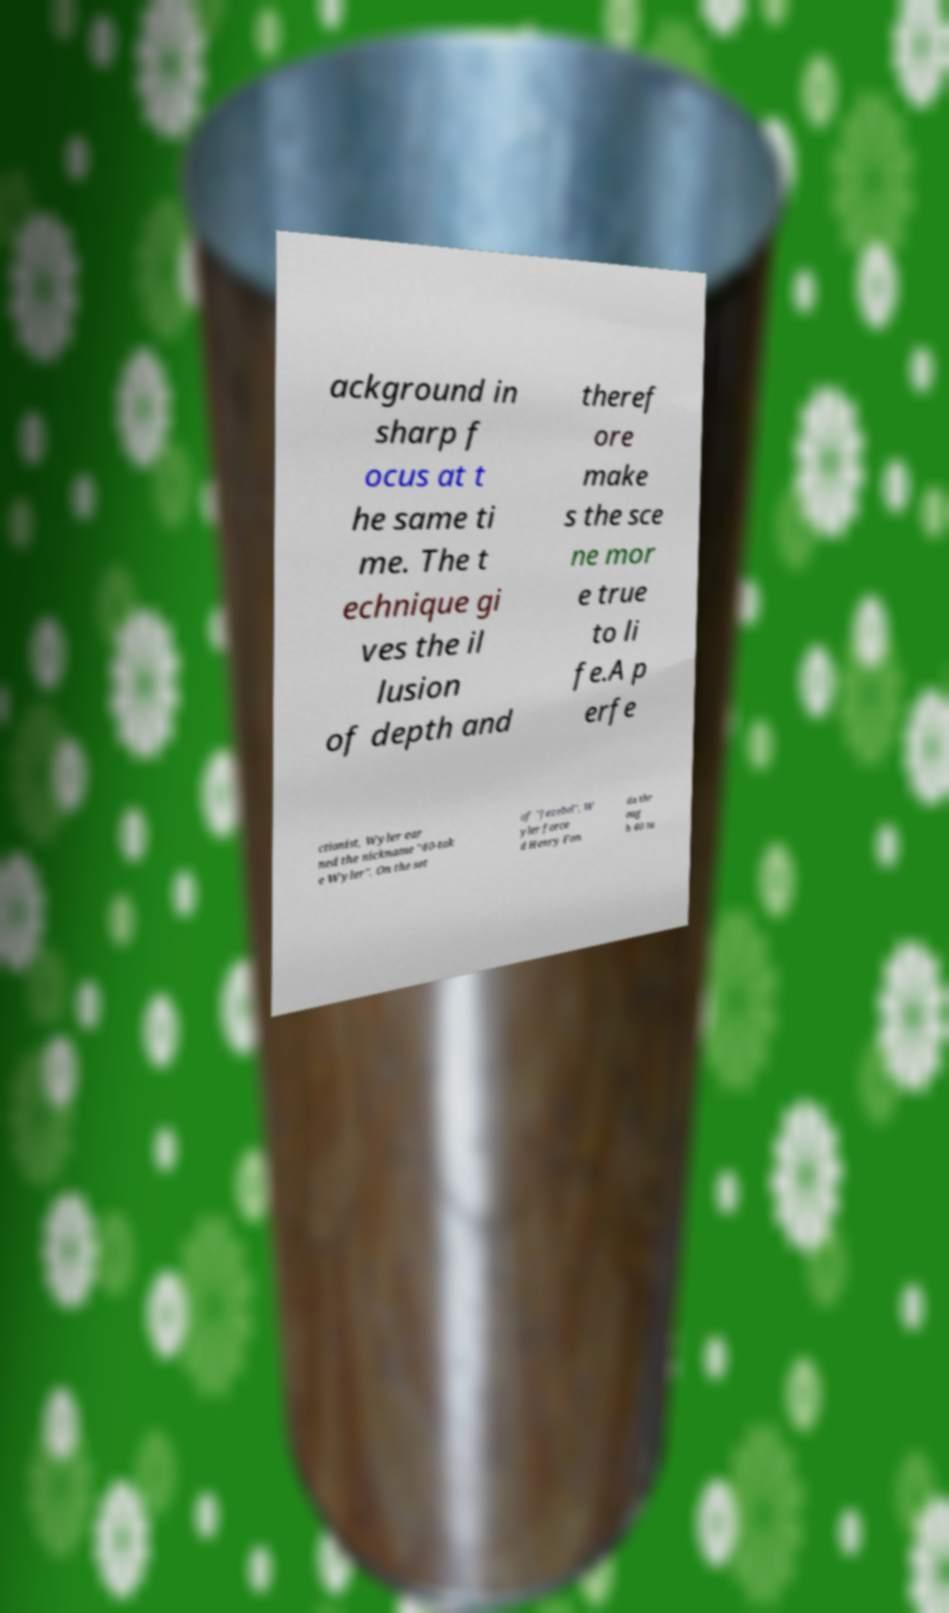Please identify and transcribe the text found in this image. ackground in sharp f ocus at t he same ti me. The t echnique gi ves the il lusion of depth and theref ore make s the sce ne mor e true to li fe.A p erfe ctionist, Wyler ear ned the nickname "40-tak e Wyler". On the set of "Jezebel", W yler force d Henry Fon da thr oug h 40 ta 